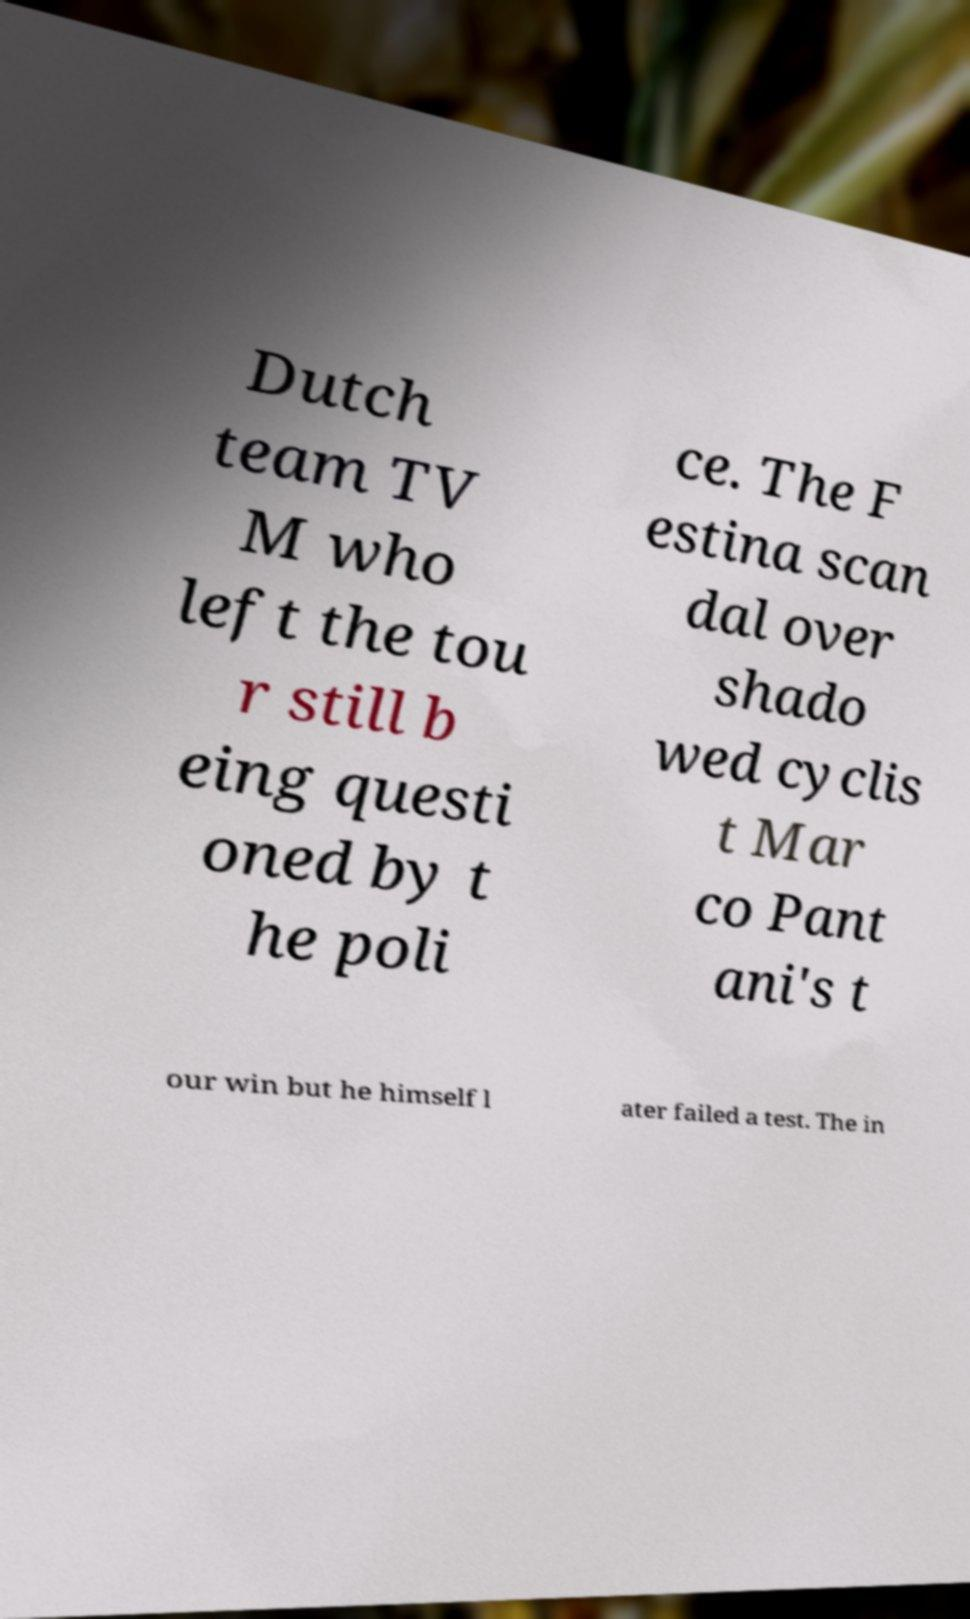What messages or text are displayed in this image? I need them in a readable, typed format. Dutch team TV M who left the tou r still b eing questi oned by t he poli ce. The F estina scan dal over shado wed cyclis t Mar co Pant ani's t our win but he himself l ater failed a test. The in 